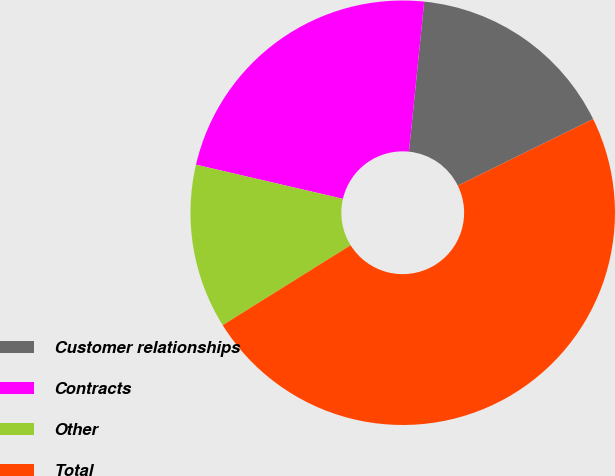<chart> <loc_0><loc_0><loc_500><loc_500><pie_chart><fcel>Customer relationships<fcel>Contracts<fcel>Other<fcel>Total<nl><fcel>16.11%<fcel>22.98%<fcel>12.52%<fcel>48.39%<nl></chart> 